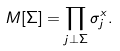<formula> <loc_0><loc_0><loc_500><loc_500>M [ \Sigma ] = \prod _ { j \bot \Sigma } \sigma ^ { x } _ { j } .</formula> 